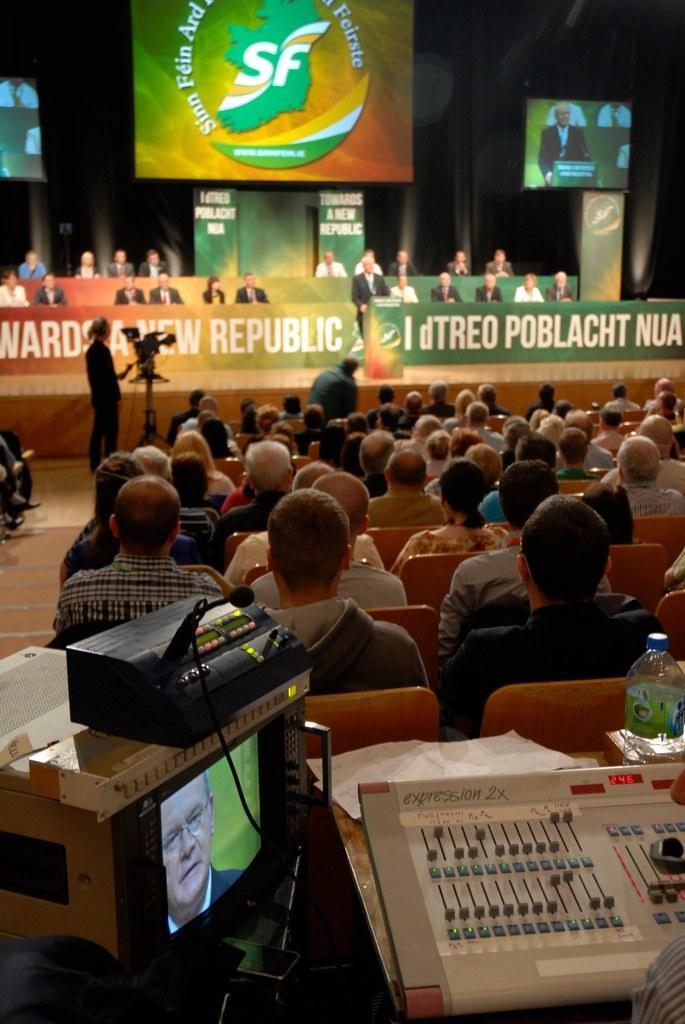How would you summarize this image in a sentence or two? In this image we can see people sitting on the chairs. Of them one is standing at the podium and the other is standing in front of the camera. In addition to this we can see display screens, disposal bottles, paper napkins and a musical instrument. 